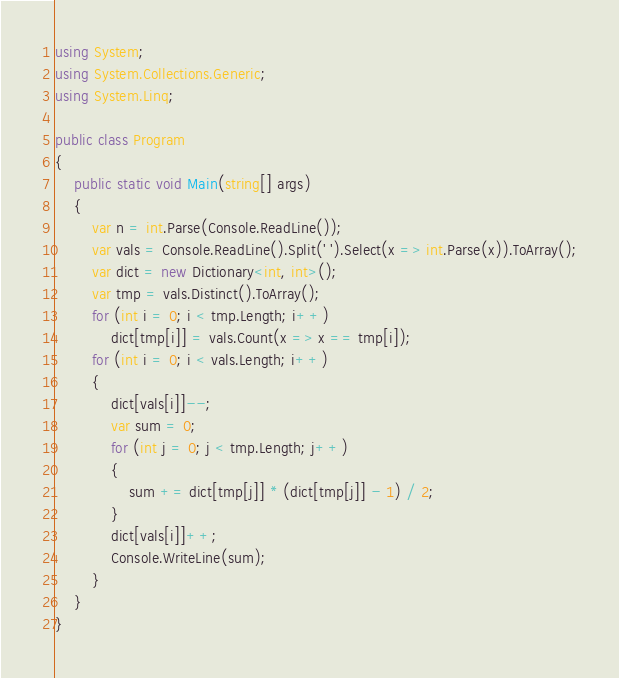Convert code to text. <code><loc_0><loc_0><loc_500><loc_500><_C#_>using System;
using System.Collections.Generic;
using System.Linq;

public class Program
{
    public static void Main(string[] args)
    {
        var n = int.Parse(Console.ReadLine());
        var vals = Console.ReadLine().Split(' ').Select(x => int.Parse(x)).ToArray();
        var dict = new Dictionary<int, int>();
        var tmp = vals.Distinct().ToArray();
        for (int i = 0; i < tmp.Length; i++)
            dict[tmp[i]] = vals.Count(x => x == tmp[i]);
        for (int i = 0; i < vals.Length; i++)
        {
            dict[vals[i]]--;
            var sum = 0;
            for (int j = 0; j < tmp.Length; j++)
            {
                sum += dict[tmp[j]] * (dict[tmp[j]] - 1) / 2;
            }
            dict[vals[i]]++;
            Console.WriteLine(sum);
        }
    }
}</code> 